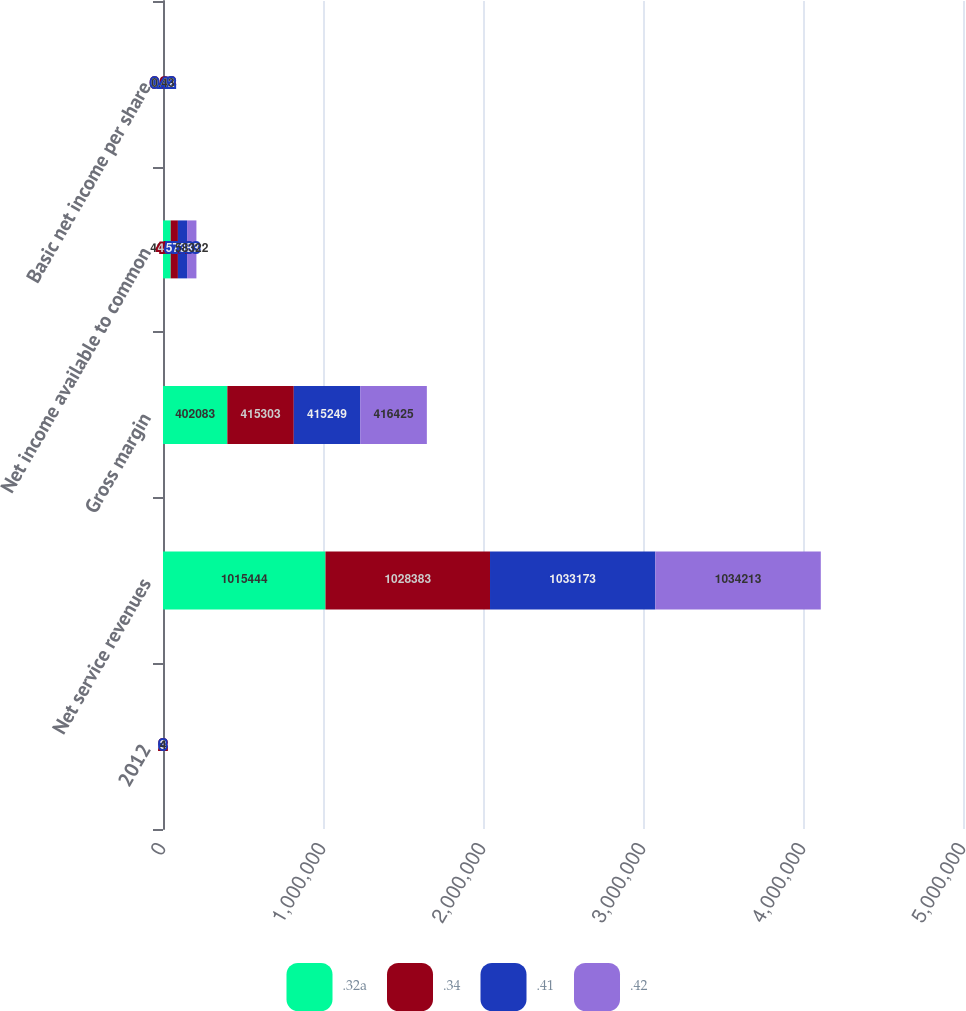<chart> <loc_0><loc_0><loc_500><loc_500><stacked_bar_chart><ecel><fcel>2012<fcel>Net service revenues<fcel>Gross margin<fcel>Net income available to common<fcel>Basic net income per share<nl><fcel>.32a<fcel>1<fcel>1.01544e+06<fcel>402083<fcel>48070<fcel>0.34<nl><fcel>.34<fcel>2<fcel>1.02838e+06<fcel>415303<fcel>45101<fcel>0.33<nl><fcel>.41<fcel>3<fcel>1.03317e+06<fcel>415249<fcel>57383<fcel>0.42<nl><fcel>.42<fcel>4<fcel>1.03421e+06<fcel>416425<fcel>58322<fcel>0.43<nl></chart> 